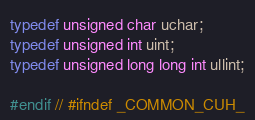<code> <loc_0><loc_0><loc_500><loc_500><_Cuda_>
typedef unsigned char uchar;
typedef unsigned int uint;
typedef unsigned long long int ullint;

#endif // #ifndef _COMMON_CUH_</code> 